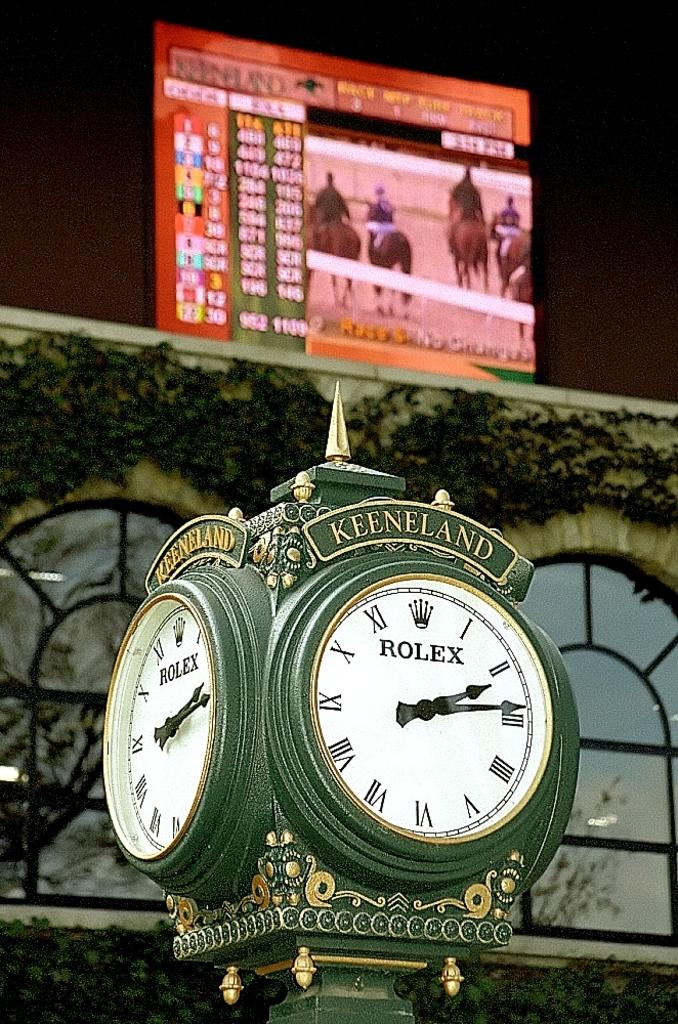<image>
Summarize the visual content of the image. A rolex clock with several faces that say Keeneland on the top. 